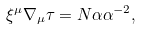Convert formula to latex. <formula><loc_0><loc_0><loc_500><loc_500>\xi ^ { \mu } \nabla _ { \mu } \tau = N \alpha \alpha ^ { - 2 } ,</formula> 